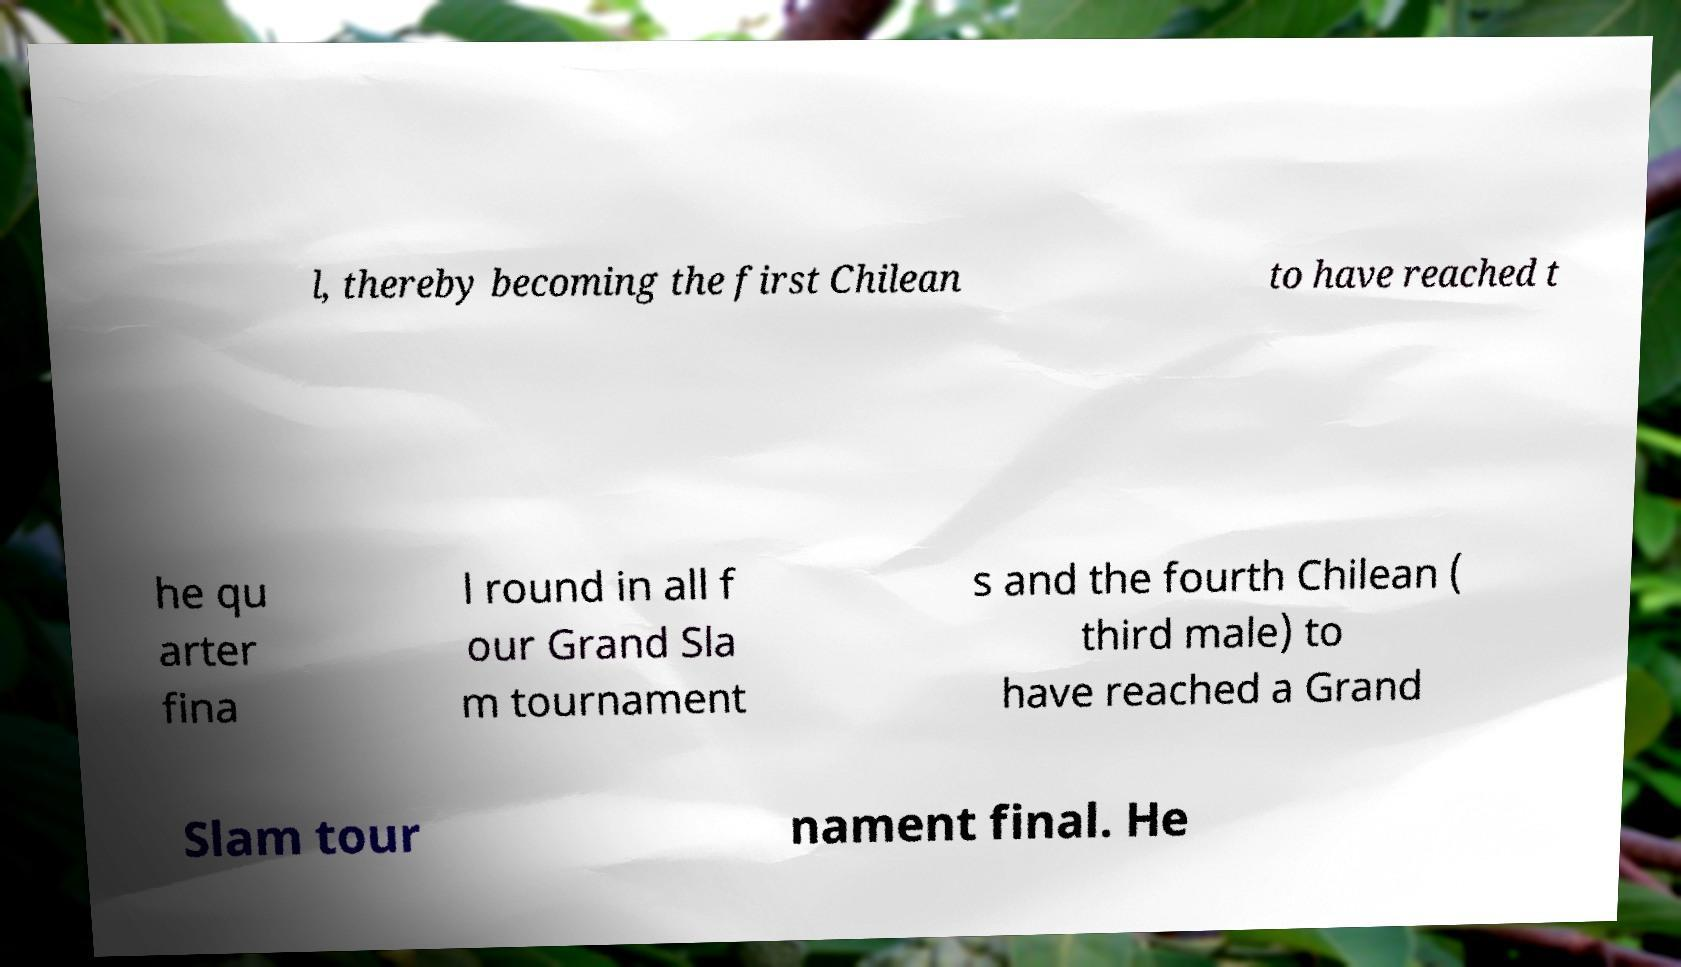I need the written content from this picture converted into text. Can you do that? l, thereby becoming the first Chilean to have reached t he qu arter fina l round in all f our Grand Sla m tournament s and the fourth Chilean ( third male) to have reached a Grand Slam tour nament final. He 